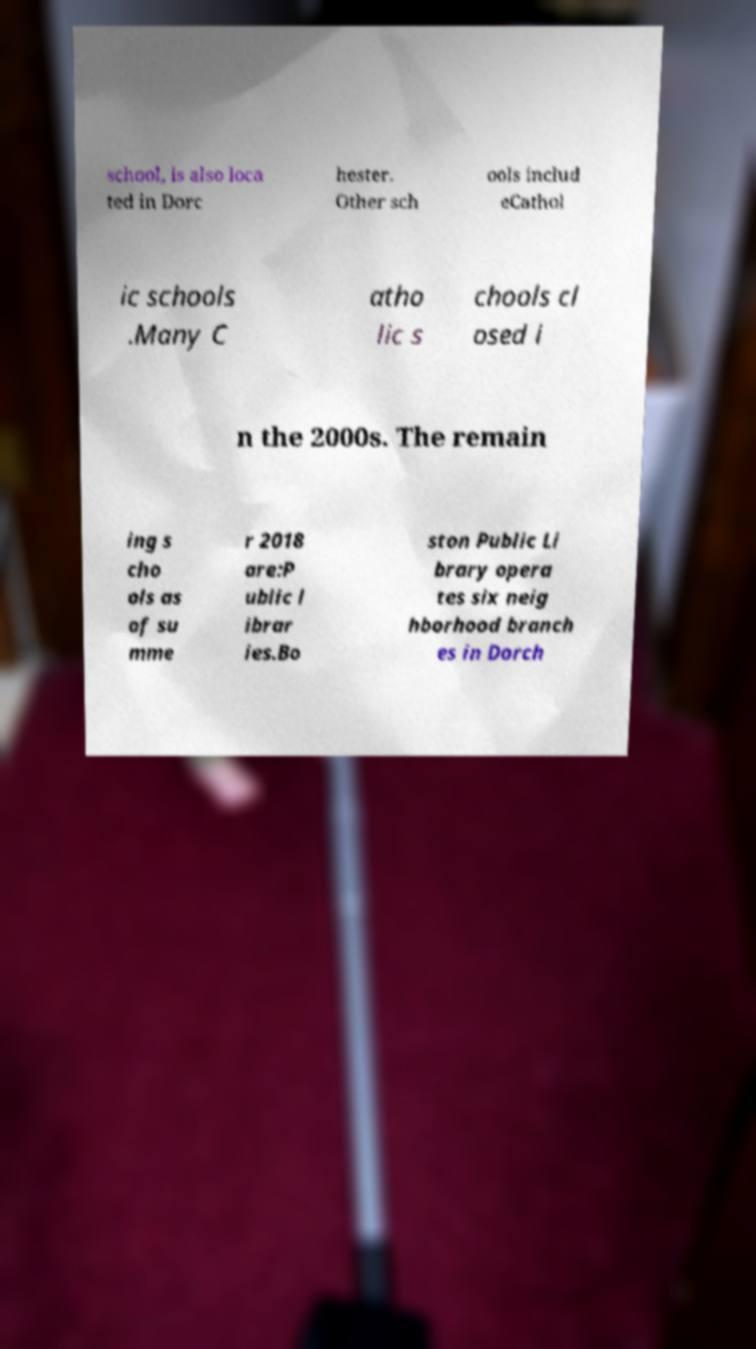Please identify and transcribe the text found in this image. school, is also loca ted in Dorc hester. Other sch ools includ eCathol ic schools .Many C atho lic s chools cl osed i n the 2000s. The remain ing s cho ols as of su mme r 2018 are:P ublic l ibrar ies.Bo ston Public Li brary opera tes six neig hborhood branch es in Dorch 